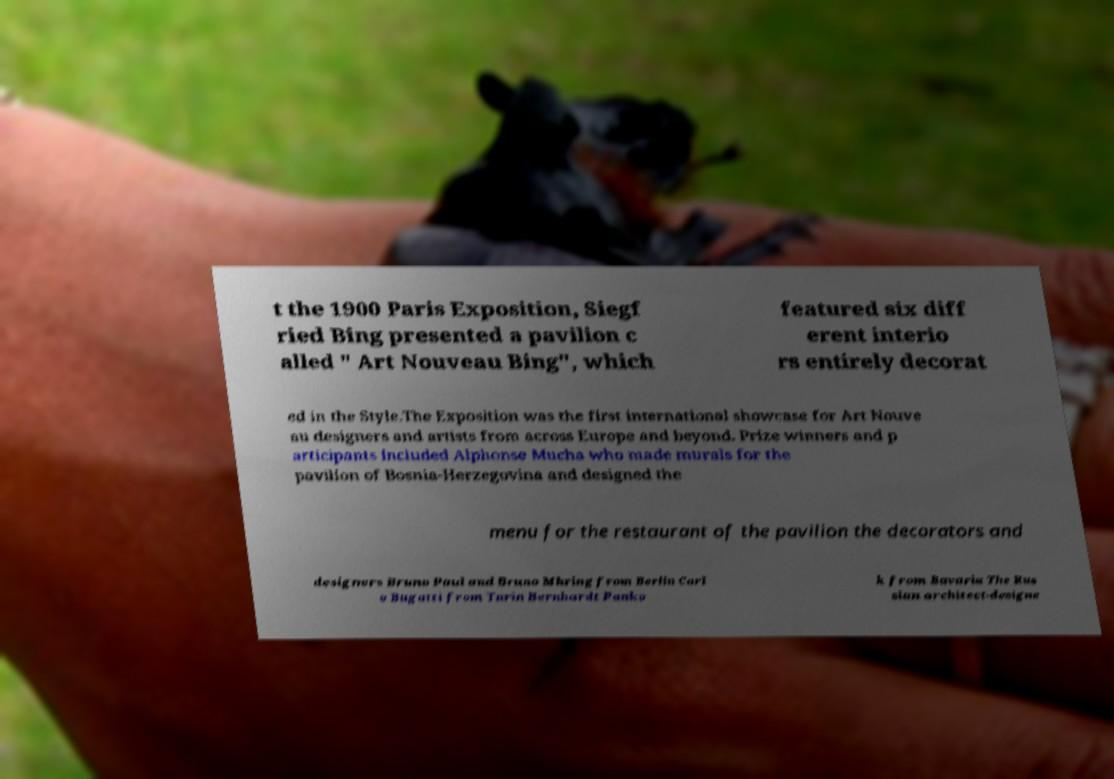What messages or text are displayed in this image? I need them in a readable, typed format. t the 1900 Paris Exposition, Siegf ried Bing presented a pavilion c alled " Art Nouveau Bing", which featured six diff erent interio rs entirely decorat ed in the Style.The Exposition was the first international showcase for Art Nouve au designers and artists from across Europe and beyond. Prize winners and p articipants included Alphonse Mucha who made murals for the pavilion of Bosnia-Herzegovina and designed the menu for the restaurant of the pavilion the decorators and designers Bruno Paul and Bruno Mhring from Berlin Carl o Bugatti from Turin Bernhardt Panko k from Bavaria The Rus sian architect-designe 